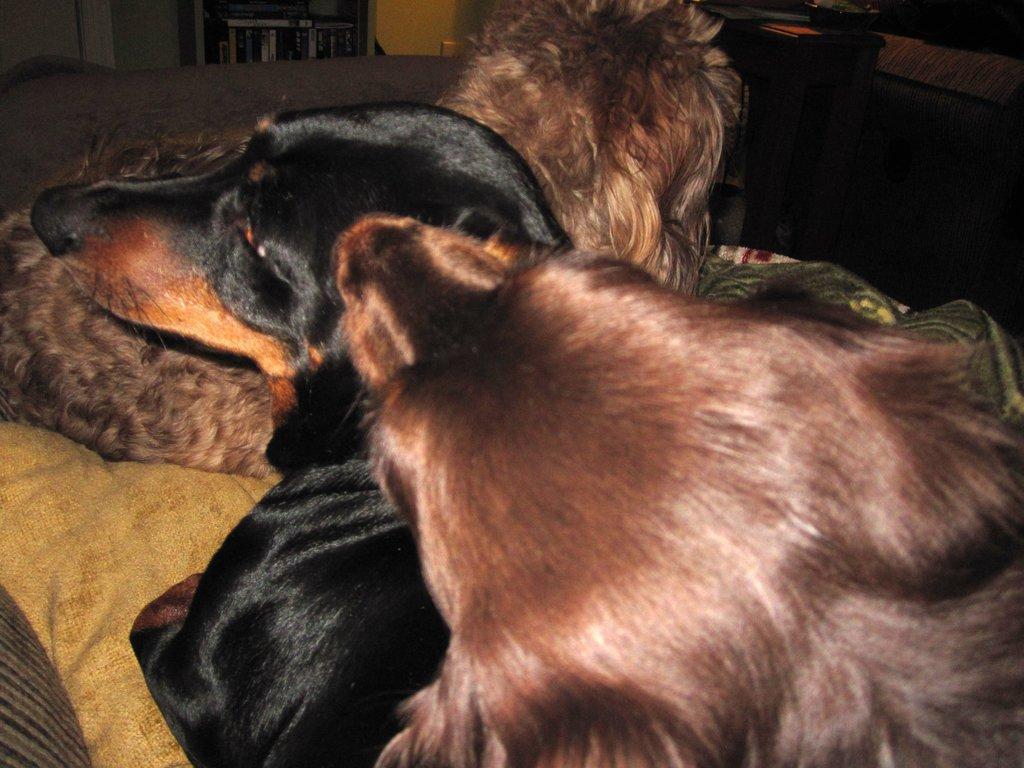How would you summarize this image in a sentence or two? At the bottom of the image we can see a couch, in the couch we can see some dogs. Behind the couch we can see a wall and table, on the table we can see some books. 